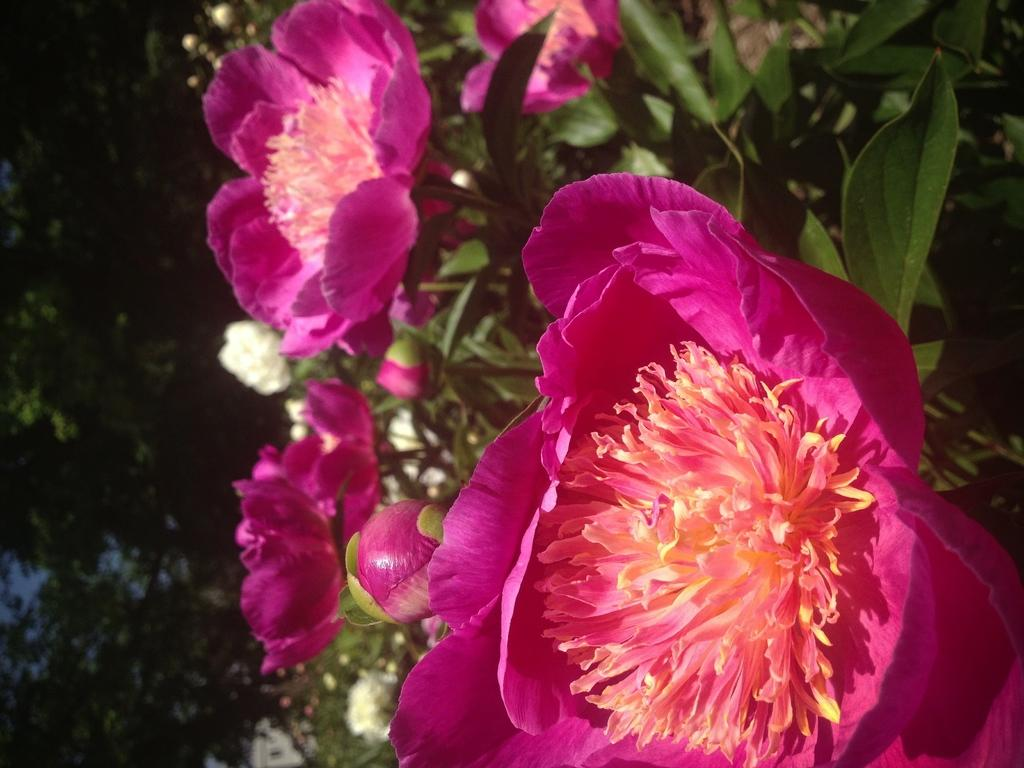What type of plants are in the image? There are flower plants in the image. What color are the flowers? The flowers are pink in color. What can be seen in the background of the image? The background of the image is dark. What type of marble is visible in the image? There is no marble present in the image. 